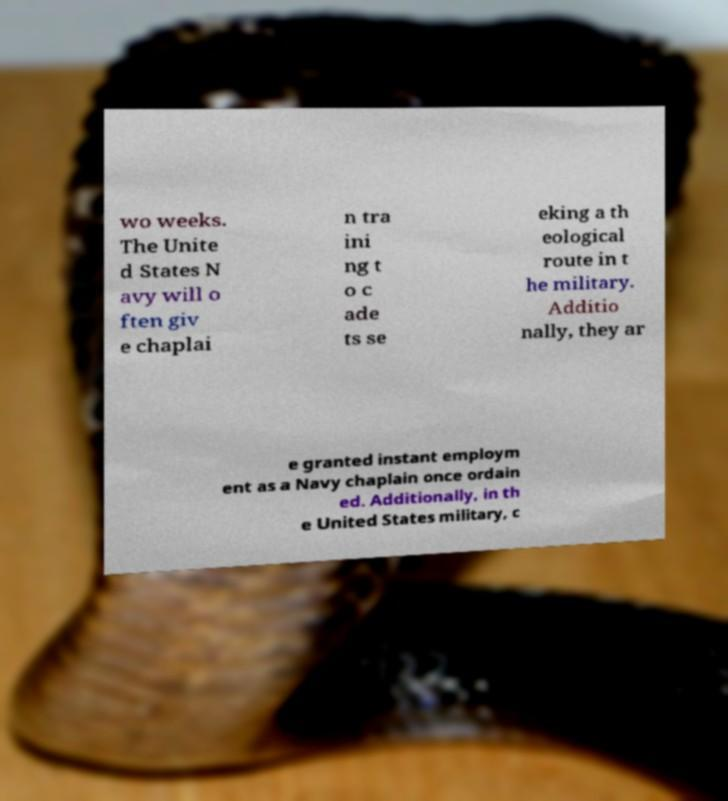Please read and relay the text visible in this image. What does it say? wo weeks. The Unite d States N avy will o ften giv e chaplai n tra ini ng t o c ade ts se eking a th eological route in t he military. Additio nally, they ar e granted instant employm ent as a Navy chaplain once ordain ed. Additionally, in th e United States military, c 